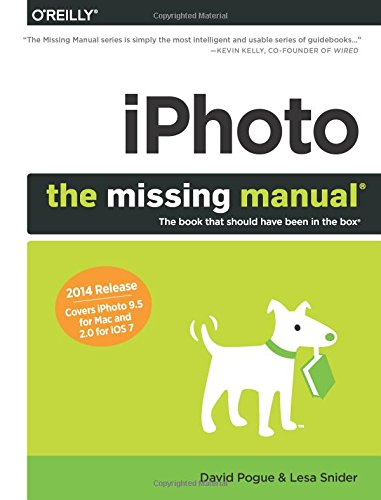What software does this book provide a manual for? This book serves as a comprehensive manual for iPhoto, a software application designed for managing and editing photos on Apple devices. 